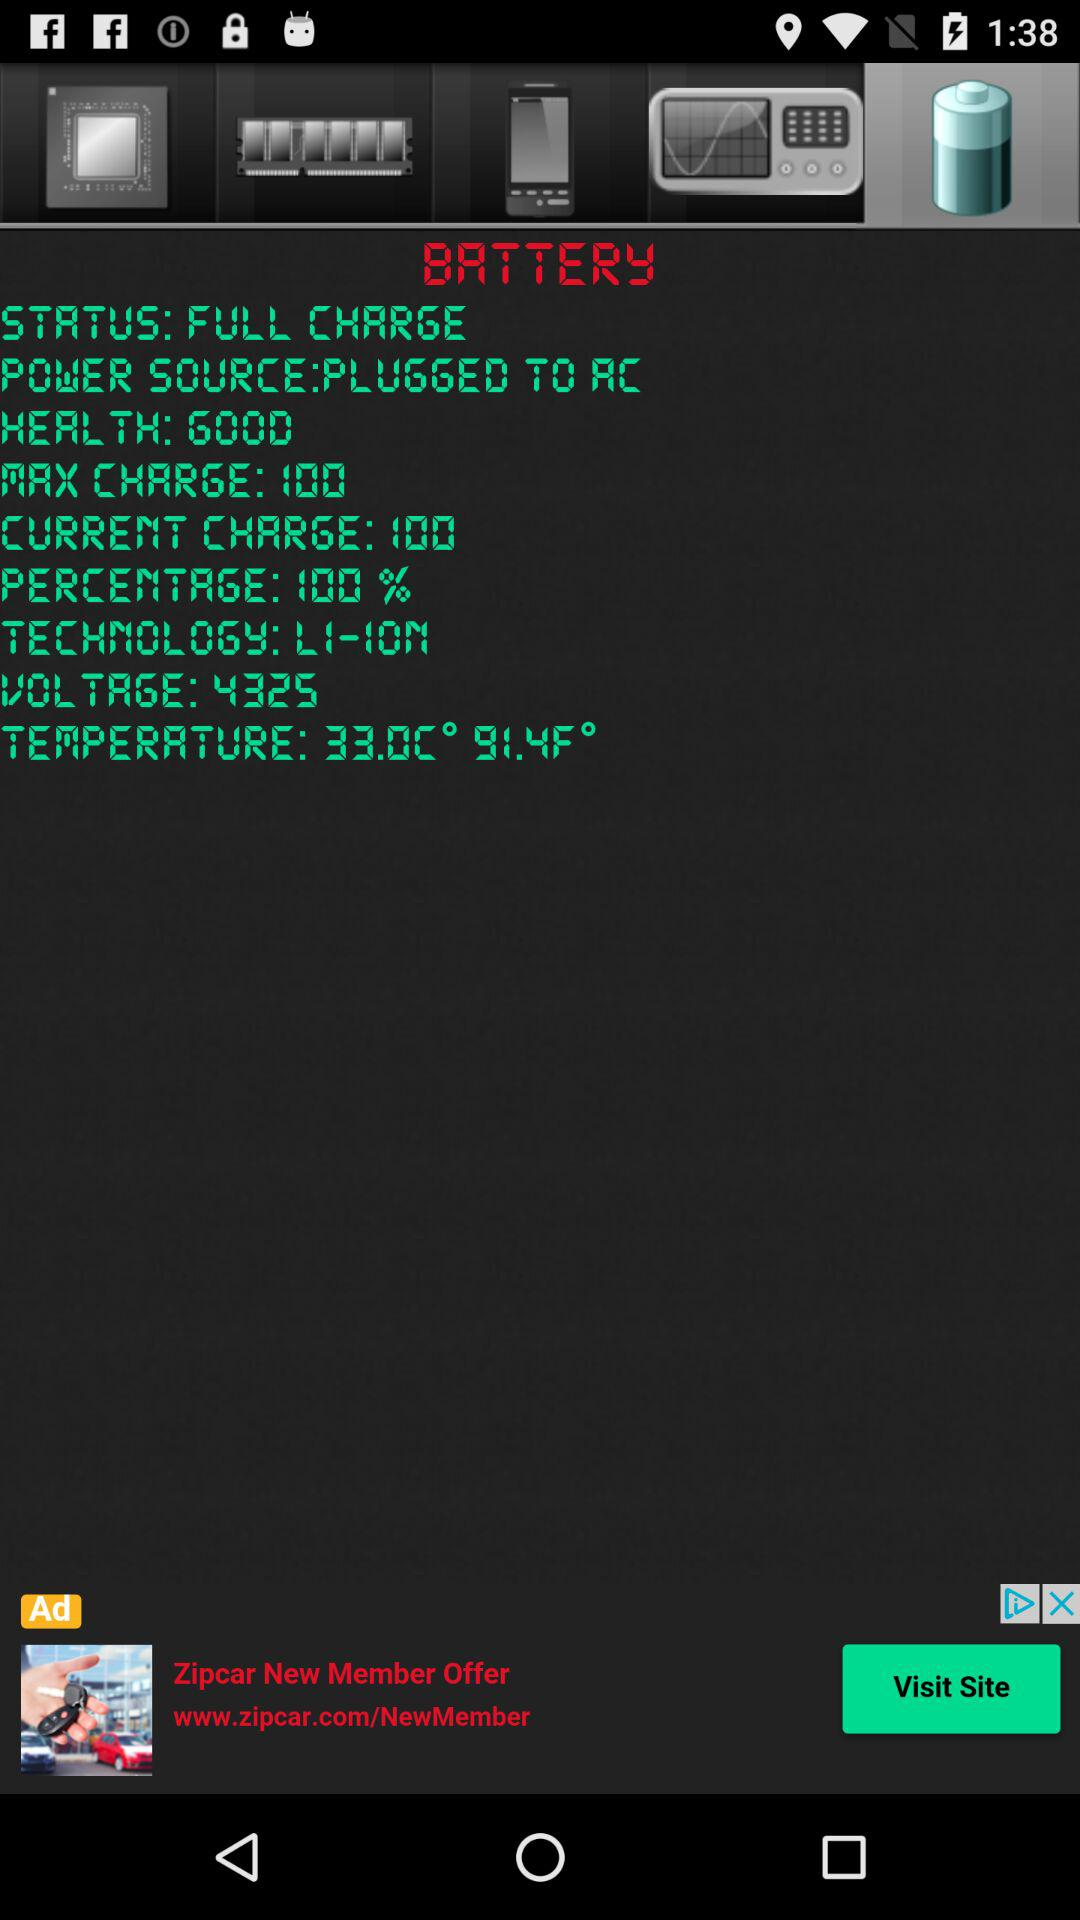What is the technology? The technology is "LI-ION". 